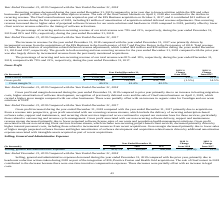According to Allscripts Healthcare Solutions's financial document, What caused the decrease in Gross profit and margin in 2019? primarily due to an increase in hosting migration costs, higher amortization of software development, recognition of previously deferred costs and the sale of OneContent business on April 2, 2018, which carried a higher gross margin compared with our other businesses. The document states: "ar ended December 31, 2019 compared to prior year primarily due to an increase in hosting migration costs, higher amortization of software development..." Also, What was the total cost of revenue in 2019? According to the financial document, $ 1,058,097 (in thousands). The relevant text states: "Total cost of revenue $ 1,058,097 $ 1,025,419 $ 864,909 3.2% 18.6%..." Also, What was the gross profit margin in 2019? According to the financial document, 40.3%. The relevant text states: "Gross margin % 40.3% 41.4% 42.3%..." Also, can you calculate: What is the change in the Total cost of revenue from 2018 to 2019? Based on the calculation: 1,058,097 - 1,025,419 , the result is 32678 (in thousands). This is based on the information: "Total cost of revenue $ 1,058,097 $ 1,025,419 $ 864,909 3.2% 18.6% Total cost of revenue $ 1,058,097 $ 1,025,419 $ 864,909 3.2% 18.6%..." The key data points involved are: 1,025,419, 1,058,097. Also, can you calculate: What is the average gross profit between 2017-2019? To answer this question, I need to perform calculations using the financial data. The calculation is: (713,580 + 724,543 + 632,799) / 3, which equals 690307.33 (in thousands). This is based on the information: "Gross profit $ 713,580 $ 724,543 $ 632,799 (1.5%) 14.5% Gross profit $ 713,580 $ 724,543 $ 632,799 (1.5%) 14.5% Gross profit $ 713,580 $ 724,543 $ 632,799 (1.5%) 14.5%..." The key data points involved are: 632,799, 713,580, 724,543. Also, can you calculate: What is the change in the gross margin % from 2018 to 2019? Based on the calculation: 40.3% - 41.4%, the result is -1.1 (percentage). This is based on the information: "Gross margin % 40.3% 41.4% 42.3% Gross margin % 40.3% 41.4% 42.3%..." The key data points involved are: 40.3, 41.4. 